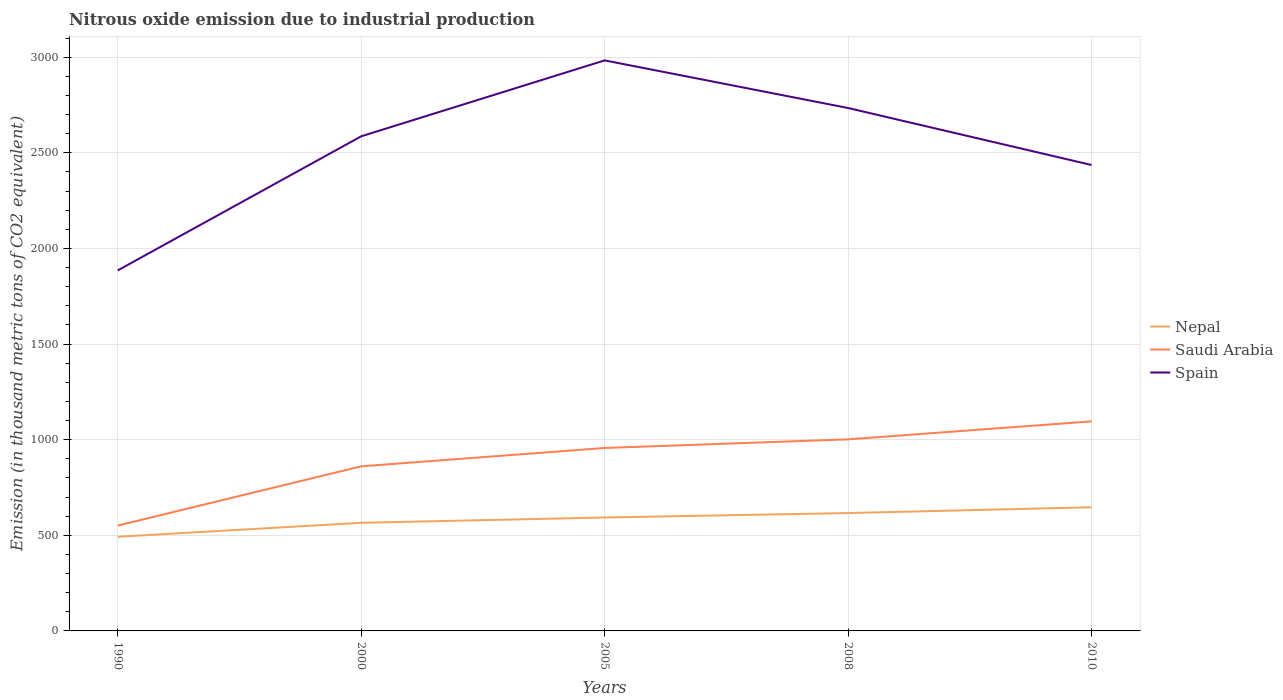Across all years, what is the maximum amount of nitrous oxide emitted in Spain?
Keep it short and to the point. 1885.3. What is the total amount of nitrous oxide emitted in Nepal in the graph?
Make the answer very short. -30.4. What is the difference between the highest and the second highest amount of nitrous oxide emitted in Nepal?
Keep it short and to the point. 154.3. What is the difference between the highest and the lowest amount of nitrous oxide emitted in Nepal?
Your answer should be very brief. 3. Is the amount of nitrous oxide emitted in Spain strictly greater than the amount of nitrous oxide emitted in Nepal over the years?
Your response must be concise. No. How many years are there in the graph?
Your answer should be very brief. 5. What is the difference between two consecutive major ticks on the Y-axis?
Keep it short and to the point. 500. Are the values on the major ticks of Y-axis written in scientific E-notation?
Offer a terse response. No. Does the graph contain any zero values?
Provide a succinct answer. No. Does the graph contain grids?
Provide a succinct answer. Yes. What is the title of the graph?
Ensure brevity in your answer.  Nitrous oxide emission due to industrial production. What is the label or title of the Y-axis?
Give a very brief answer. Emission (in thousand metric tons of CO2 equivalent). What is the Emission (in thousand metric tons of CO2 equivalent) of Nepal in 1990?
Provide a succinct answer. 492.4. What is the Emission (in thousand metric tons of CO2 equivalent) of Saudi Arabia in 1990?
Provide a succinct answer. 550.9. What is the Emission (in thousand metric tons of CO2 equivalent) of Spain in 1990?
Keep it short and to the point. 1885.3. What is the Emission (in thousand metric tons of CO2 equivalent) of Nepal in 2000?
Make the answer very short. 565.3. What is the Emission (in thousand metric tons of CO2 equivalent) of Saudi Arabia in 2000?
Make the answer very short. 860.7. What is the Emission (in thousand metric tons of CO2 equivalent) of Spain in 2000?
Your answer should be very brief. 2586.5. What is the Emission (in thousand metric tons of CO2 equivalent) of Nepal in 2005?
Give a very brief answer. 593.1. What is the Emission (in thousand metric tons of CO2 equivalent) in Saudi Arabia in 2005?
Your answer should be very brief. 956.7. What is the Emission (in thousand metric tons of CO2 equivalent) of Spain in 2005?
Your answer should be compact. 2983.4. What is the Emission (in thousand metric tons of CO2 equivalent) of Nepal in 2008?
Offer a very short reply. 616.3. What is the Emission (in thousand metric tons of CO2 equivalent) in Saudi Arabia in 2008?
Ensure brevity in your answer.  1001.7. What is the Emission (in thousand metric tons of CO2 equivalent) in Spain in 2008?
Your response must be concise. 2734.4. What is the Emission (in thousand metric tons of CO2 equivalent) of Nepal in 2010?
Your answer should be very brief. 646.7. What is the Emission (in thousand metric tons of CO2 equivalent) in Saudi Arabia in 2010?
Offer a terse response. 1095.8. What is the Emission (in thousand metric tons of CO2 equivalent) in Spain in 2010?
Keep it short and to the point. 2436.4. Across all years, what is the maximum Emission (in thousand metric tons of CO2 equivalent) in Nepal?
Provide a succinct answer. 646.7. Across all years, what is the maximum Emission (in thousand metric tons of CO2 equivalent) of Saudi Arabia?
Give a very brief answer. 1095.8. Across all years, what is the maximum Emission (in thousand metric tons of CO2 equivalent) in Spain?
Your answer should be very brief. 2983.4. Across all years, what is the minimum Emission (in thousand metric tons of CO2 equivalent) in Nepal?
Provide a short and direct response. 492.4. Across all years, what is the minimum Emission (in thousand metric tons of CO2 equivalent) in Saudi Arabia?
Your answer should be compact. 550.9. Across all years, what is the minimum Emission (in thousand metric tons of CO2 equivalent) of Spain?
Ensure brevity in your answer.  1885.3. What is the total Emission (in thousand metric tons of CO2 equivalent) of Nepal in the graph?
Offer a terse response. 2913.8. What is the total Emission (in thousand metric tons of CO2 equivalent) of Saudi Arabia in the graph?
Ensure brevity in your answer.  4465.8. What is the total Emission (in thousand metric tons of CO2 equivalent) of Spain in the graph?
Your answer should be compact. 1.26e+04. What is the difference between the Emission (in thousand metric tons of CO2 equivalent) of Nepal in 1990 and that in 2000?
Provide a short and direct response. -72.9. What is the difference between the Emission (in thousand metric tons of CO2 equivalent) in Saudi Arabia in 1990 and that in 2000?
Your answer should be very brief. -309.8. What is the difference between the Emission (in thousand metric tons of CO2 equivalent) of Spain in 1990 and that in 2000?
Keep it short and to the point. -701.2. What is the difference between the Emission (in thousand metric tons of CO2 equivalent) in Nepal in 1990 and that in 2005?
Give a very brief answer. -100.7. What is the difference between the Emission (in thousand metric tons of CO2 equivalent) of Saudi Arabia in 1990 and that in 2005?
Provide a short and direct response. -405.8. What is the difference between the Emission (in thousand metric tons of CO2 equivalent) of Spain in 1990 and that in 2005?
Keep it short and to the point. -1098.1. What is the difference between the Emission (in thousand metric tons of CO2 equivalent) in Nepal in 1990 and that in 2008?
Offer a very short reply. -123.9. What is the difference between the Emission (in thousand metric tons of CO2 equivalent) of Saudi Arabia in 1990 and that in 2008?
Provide a succinct answer. -450.8. What is the difference between the Emission (in thousand metric tons of CO2 equivalent) of Spain in 1990 and that in 2008?
Your answer should be very brief. -849.1. What is the difference between the Emission (in thousand metric tons of CO2 equivalent) in Nepal in 1990 and that in 2010?
Your answer should be very brief. -154.3. What is the difference between the Emission (in thousand metric tons of CO2 equivalent) of Saudi Arabia in 1990 and that in 2010?
Offer a very short reply. -544.9. What is the difference between the Emission (in thousand metric tons of CO2 equivalent) in Spain in 1990 and that in 2010?
Your answer should be very brief. -551.1. What is the difference between the Emission (in thousand metric tons of CO2 equivalent) of Nepal in 2000 and that in 2005?
Offer a terse response. -27.8. What is the difference between the Emission (in thousand metric tons of CO2 equivalent) in Saudi Arabia in 2000 and that in 2005?
Provide a succinct answer. -96. What is the difference between the Emission (in thousand metric tons of CO2 equivalent) of Spain in 2000 and that in 2005?
Ensure brevity in your answer.  -396.9. What is the difference between the Emission (in thousand metric tons of CO2 equivalent) in Nepal in 2000 and that in 2008?
Keep it short and to the point. -51. What is the difference between the Emission (in thousand metric tons of CO2 equivalent) in Saudi Arabia in 2000 and that in 2008?
Provide a succinct answer. -141. What is the difference between the Emission (in thousand metric tons of CO2 equivalent) in Spain in 2000 and that in 2008?
Provide a succinct answer. -147.9. What is the difference between the Emission (in thousand metric tons of CO2 equivalent) in Nepal in 2000 and that in 2010?
Your answer should be compact. -81.4. What is the difference between the Emission (in thousand metric tons of CO2 equivalent) in Saudi Arabia in 2000 and that in 2010?
Ensure brevity in your answer.  -235.1. What is the difference between the Emission (in thousand metric tons of CO2 equivalent) of Spain in 2000 and that in 2010?
Keep it short and to the point. 150.1. What is the difference between the Emission (in thousand metric tons of CO2 equivalent) of Nepal in 2005 and that in 2008?
Keep it short and to the point. -23.2. What is the difference between the Emission (in thousand metric tons of CO2 equivalent) in Saudi Arabia in 2005 and that in 2008?
Provide a short and direct response. -45. What is the difference between the Emission (in thousand metric tons of CO2 equivalent) in Spain in 2005 and that in 2008?
Offer a terse response. 249. What is the difference between the Emission (in thousand metric tons of CO2 equivalent) in Nepal in 2005 and that in 2010?
Offer a very short reply. -53.6. What is the difference between the Emission (in thousand metric tons of CO2 equivalent) of Saudi Arabia in 2005 and that in 2010?
Offer a very short reply. -139.1. What is the difference between the Emission (in thousand metric tons of CO2 equivalent) of Spain in 2005 and that in 2010?
Offer a very short reply. 547. What is the difference between the Emission (in thousand metric tons of CO2 equivalent) of Nepal in 2008 and that in 2010?
Your answer should be very brief. -30.4. What is the difference between the Emission (in thousand metric tons of CO2 equivalent) in Saudi Arabia in 2008 and that in 2010?
Keep it short and to the point. -94.1. What is the difference between the Emission (in thousand metric tons of CO2 equivalent) in Spain in 2008 and that in 2010?
Offer a terse response. 298. What is the difference between the Emission (in thousand metric tons of CO2 equivalent) in Nepal in 1990 and the Emission (in thousand metric tons of CO2 equivalent) in Saudi Arabia in 2000?
Make the answer very short. -368.3. What is the difference between the Emission (in thousand metric tons of CO2 equivalent) in Nepal in 1990 and the Emission (in thousand metric tons of CO2 equivalent) in Spain in 2000?
Give a very brief answer. -2094.1. What is the difference between the Emission (in thousand metric tons of CO2 equivalent) in Saudi Arabia in 1990 and the Emission (in thousand metric tons of CO2 equivalent) in Spain in 2000?
Your answer should be very brief. -2035.6. What is the difference between the Emission (in thousand metric tons of CO2 equivalent) in Nepal in 1990 and the Emission (in thousand metric tons of CO2 equivalent) in Saudi Arabia in 2005?
Give a very brief answer. -464.3. What is the difference between the Emission (in thousand metric tons of CO2 equivalent) of Nepal in 1990 and the Emission (in thousand metric tons of CO2 equivalent) of Spain in 2005?
Provide a short and direct response. -2491. What is the difference between the Emission (in thousand metric tons of CO2 equivalent) in Saudi Arabia in 1990 and the Emission (in thousand metric tons of CO2 equivalent) in Spain in 2005?
Keep it short and to the point. -2432.5. What is the difference between the Emission (in thousand metric tons of CO2 equivalent) in Nepal in 1990 and the Emission (in thousand metric tons of CO2 equivalent) in Saudi Arabia in 2008?
Keep it short and to the point. -509.3. What is the difference between the Emission (in thousand metric tons of CO2 equivalent) of Nepal in 1990 and the Emission (in thousand metric tons of CO2 equivalent) of Spain in 2008?
Keep it short and to the point. -2242. What is the difference between the Emission (in thousand metric tons of CO2 equivalent) in Saudi Arabia in 1990 and the Emission (in thousand metric tons of CO2 equivalent) in Spain in 2008?
Keep it short and to the point. -2183.5. What is the difference between the Emission (in thousand metric tons of CO2 equivalent) in Nepal in 1990 and the Emission (in thousand metric tons of CO2 equivalent) in Saudi Arabia in 2010?
Keep it short and to the point. -603.4. What is the difference between the Emission (in thousand metric tons of CO2 equivalent) in Nepal in 1990 and the Emission (in thousand metric tons of CO2 equivalent) in Spain in 2010?
Your answer should be compact. -1944. What is the difference between the Emission (in thousand metric tons of CO2 equivalent) of Saudi Arabia in 1990 and the Emission (in thousand metric tons of CO2 equivalent) of Spain in 2010?
Your response must be concise. -1885.5. What is the difference between the Emission (in thousand metric tons of CO2 equivalent) of Nepal in 2000 and the Emission (in thousand metric tons of CO2 equivalent) of Saudi Arabia in 2005?
Offer a terse response. -391.4. What is the difference between the Emission (in thousand metric tons of CO2 equivalent) in Nepal in 2000 and the Emission (in thousand metric tons of CO2 equivalent) in Spain in 2005?
Offer a very short reply. -2418.1. What is the difference between the Emission (in thousand metric tons of CO2 equivalent) in Saudi Arabia in 2000 and the Emission (in thousand metric tons of CO2 equivalent) in Spain in 2005?
Provide a succinct answer. -2122.7. What is the difference between the Emission (in thousand metric tons of CO2 equivalent) in Nepal in 2000 and the Emission (in thousand metric tons of CO2 equivalent) in Saudi Arabia in 2008?
Ensure brevity in your answer.  -436.4. What is the difference between the Emission (in thousand metric tons of CO2 equivalent) of Nepal in 2000 and the Emission (in thousand metric tons of CO2 equivalent) of Spain in 2008?
Your answer should be compact. -2169.1. What is the difference between the Emission (in thousand metric tons of CO2 equivalent) in Saudi Arabia in 2000 and the Emission (in thousand metric tons of CO2 equivalent) in Spain in 2008?
Your answer should be very brief. -1873.7. What is the difference between the Emission (in thousand metric tons of CO2 equivalent) in Nepal in 2000 and the Emission (in thousand metric tons of CO2 equivalent) in Saudi Arabia in 2010?
Your answer should be very brief. -530.5. What is the difference between the Emission (in thousand metric tons of CO2 equivalent) in Nepal in 2000 and the Emission (in thousand metric tons of CO2 equivalent) in Spain in 2010?
Make the answer very short. -1871.1. What is the difference between the Emission (in thousand metric tons of CO2 equivalent) in Saudi Arabia in 2000 and the Emission (in thousand metric tons of CO2 equivalent) in Spain in 2010?
Your response must be concise. -1575.7. What is the difference between the Emission (in thousand metric tons of CO2 equivalent) of Nepal in 2005 and the Emission (in thousand metric tons of CO2 equivalent) of Saudi Arabia in 2008?
Offer a very short reply. -408.6. What is the difference between the Emission (in thousand metric tons of CO2 equivalent) of Nepal in 2005 and the Emission (in thousand metric tons of CO2 equivalent) of Spain in 2008?
Give a very brief answer. -2141.3. What is the difference between the Emission (in thousand metric tons of CO2 equivalent) of Saudi Arabia in 2005 and the Emission (in thousand metric tons of CO2 equivalent) of Spain in 2008?
Provide a short and direct response. -1777.7. What is the difference between the Emission (in thousand metric tons of CO2 equivalent) in Nepal in 2005 and the Emission (in thousand metric tons of CO2 equivalent) in Saudi Arabia in 2010?
Provide a succinct answer. -502.7. What is the difference between the Emission (in thousand metric tons of CO2 equivalent) of Nepal in 2005 and the Emission (in thousand metric tons of CO2 equivalent) of Spain in 2010?
Provide a short and direct response. -1843.3. What is the difference between the Emission (in thousand metric tons of CO2 equivalent) of Saudi Arabia in 2005 and the Emission (in thousand metric tons of CO2 equivalent) of Spain in 2010?
Make the answer very short. -1479.7. What is the difference between the Emission (in thousand metric tons of CO2 equivalent) of Nepal in 2008 and the Emission (in thousand metric tons of CO2 equivalent) of Saudi Arabia in 2010?
Give a very brief answer. -479.5. What is the difference between the Emission (in thousand metric tons of CO2 equivalent) in Nepal in 2008 and the Emission (in thousand metric tons of CO2 equivalent) in Spain in 2010?
Give a very brief answer. -1820.1. What is the difference between the Emission (in thousand metric tons of CO2 equivalent) in Saudi Arabia in 2008 and the Emission (in thousand metric tons of CO2 equivalent) in Spain in 2010?
Your answer should be compact. -1434.7. What is the average Emission (in thousand metric tons of CO2 equivalent) in Nepal per year?
Offer a very short reply. 582.76. What is the average Emission (in thousand metric tons of CO2 equivalent) of Saudi Arabia per year?
Keep it short and to the point. 893.16. What is the average Emission (in thousand metric tons of CO2 equivalent) in Spain per year?
Your answer should be very brief. 2525.2. In the year 1990, what is the difference between the Emission (in thousand metric tons of CO2 equivalent) of Nepal and Emission (in thousand metric tons of CO2 equivalent) of Saudi Arabia?
Ensure brevity in your answer.  -58.5. In the year 1990, what is the difference between the Emission (in thousand metric tons of CO2 equivalent) of Nepal and Emission (in thousand metric tons of CO2 equivalent) of Spain?
Ensure brevity in your answer.  -1392.9. In the year 1990, what is the difference between the Emission (in thousand metric tons of CO2 equivalent) of Saudi Arabia and Emission (in thousand metric tons of CO2 equivalent) of Spain?
Keep it short and to the point. -1334.4. In the year 2000, what is the difference between the Emission (in thousand metric tons of CO2 equivalent) of Nepal and Emission (in thousand metric tons of CO2 equivalent) of Saudi Arabia?
Provide a short and direct response. -295.4. In the year 2000, what is the difference between the Emission (in thousand metric tons of CO2 equivalent) in Nepal and Emission (in thousand metric tons of CO2 equivalent) in Spain?
Offer a terse response. -2021.2. In the year 2000, what is the difference between the Emission (in thousand metric tons of CO2 equivalent) in Saudi Arabia and Emission (in thousand metric tons of CO2 equivalent) in Spain?
Provide a succinct answer. -1725.8. In the year 2005, what is the difference between the Emission (in thousand metric tons of CO2 equivalent) of Nepal and Emission (in thousand metric tons of CO2 equivalent) of Saudi Arabia?
Keep it short and to the point. -363.6. In the year 2005, what is the difference between the Emission (in thousand metric tons of CO2 equivalent) of Nepal and Emission (in thousand metric tons of CO2 equivalent) of Spain?
Your answer should be compact. -2390.3. In the year 2005, what is the difference between the Emission (in thousand metric tons of CO2 equivalent) in Saudi Arabia and Emission (in thousand metric tons of CO2 equivalent) in Spain?
Provide a succinct answer. -2026.7. In the year 2008, what is the difference between the Emission (in thousand metric tons of CO2 equivalent) in Nepal and Emission (in thousand metric tons of CO2 equivalent) in Saudi Arabia?
Your answer should be compact. -385.4. In the year 2008, what is the difference between the Emission (in thousand metric tons of CO2 equivalent) in Nepal and Emission (in thousand metric tons of CO2 equivalent) in Spain?
Provide a succinct answer. -2118.1. In the year 2008, what is the difference between the Emission (in thousand metric tons of CO2 equivalent) of Saudi Arabia and Emission (in thousand metric tons of CO2 equivalent) of Spain?
Offer a very short reply. -1732.7. In the year 2010, what is the difference between the Emission (in thousand metric tons of CO2 equivalent) of Nepal and Emission (in thousand metric tons of CO2 equivalent) of Saudi Arabia?
Give a very brief answer. -449.1. In the year 2010, what is the difference between the Emission (in thousand metric tons of CO2 equivalent) of Nepal and Emission (in thousand metric tons of CO2 equivalent) of Spain?
Keep it short and to the point. -1789.7. In the year 2010, what is the difference between the Emission (in thousand metric tons of CO2 equivalent) of Saudi Arabia and Emission (in thousand metric tons of CO2 equivalent) of Spain?
Provide a succinct answer. -1340.6. What is the ratio of the Emission (in thousand metric tons of CO2 equivalent) of Nepal in 1990 to that in 2000?
Your response must be concise. 0.87. What is the ratio of the Emission (in thousand metric tons of CO2 equivalent) in Saudi Arabia in 1990 to that in 2000?
Offer a terse response. 0.64. What is the ratio of the Emission (in thousand metric tons of CO2 equivalent) in Spain in 1990 to that in 2000?
Keep it short and to the point. 0.73. What is the ratio of the Emission (in thousand metric tons of CO2 equivalent) in Nepal in 1990 to that in 2005?
Your answer should be compact. 0.83. What is the ratio of the Emission (in thousand metric tons of CO2 equivalent) of Saudi Arabia in 1990 to that in 2005?
Offer a terse response. 0.58. What is the ratio of the Emission (in thousand metric tons of CO2 equivalent) in Spain in 1990 to that in 2005?
Ensure brevity in your answer.  0.63. What is the ratio of the Emission (in thousand metric tons of CO2 equivalent) in Nepal in 1990 to that in 2008?
Give a very brief answer. 0.8. What is the ratio of the Emission (in thousand metric tons of CO2 equivalent) of Saudi Arabia in 1990 to that in 2008?
Give a very brief answer. 0.55. What is the ratio of the Emission (in thousand metric tons of CO2 equivalent) of Spain in 1990 to that in 2008?
Your answer should be very brief. 0.69. What is the ratio of the Emission (in thousand metric tons of CO2 equivalent) of Nepal in 1990 to that in 2010?
Ensure brevity in your answer.  0.76. What is the ratio of the Emission (in thousand metric tons of CO2 equivalent) in Saudi Arabia in 1990 to that in 2010?
Your answer should be compact. 0.5. What is the ratio of the Emission (in thousand metric tons of CO2 equivalent) in Spain in 1990 to that in 2010?
Make the answer very short. 0.77. What is the ratio of the Emission (in thousand metric tons of CO2 equivalent) in Nepal in 2000 to that in 2005?
Give a very brief answer. 0.95. What is the ratio of the Emission (in thousand metric tons of CO2 equivalent) of Saudi Arabia in 2000 to that in 2005?
Your answer should be very brief. 0.9. What is the ratio of the Emission (in thousand metric tons of CO2 equivalent) in Spain in 2000 to that in 2005?
Offer a very short reply. 0.87. What is the ratio of the Emission (in thousand metric tons of CO2 equivalent) of Nepal in 2000 to that in 2008?
Provide a short and direct response. 0.92. What is the ratio of the Emission (in thousand metric tons of CO2 equivalent) of Saudi Arabia in 2000 to that in 2008?
Offer a terse response. 0.86. What is the ratio of the Emission (in thousand metric tons of CO2 equivalent) of Spain in 2000 to that in 2008?
Provide a short and direct response. 0.95. What is the ratio of the Emission (in thousand metric tons of CO2 equivalent) in Nepal in 2000 to that in 2010?
Offer a terse response. 0.87. What is the ratio of the Emission (in thousand metric tons of CO2 equivalent) in Saudi Arabia in 2000 to that in 2010?
Provide a succinct answer. 0.79. What is the ratio of the Emission (in thousand metric tons of CO2 equivalent) of Spain in 2000 to that in 2010?
Ensure brevity in your answer.  1.06. What is the ratio of the Emission (in thousand metric tons of CO2 equivalent) in Nepal in 2005 to that in 2008?
Your response must be concise. 0.96. What is the ratio of the Emission (in thousand metric tons of CO2 equivalent) of Saudi Arabia in 2005 to that in 2008?
Offer a terse response. 0.96. What is the ratio of the Emission (in thousand metric tons of CO2 equivalent) of Spain in 2005 to that in 2008?
Provide a short and direct response. 1.09. What is the ratio of the Emission (in thousand metric tons of CO2 equivalent) of Nepal in 2005 to that in 2010?
Your response must be concise. 0.92. What is the ratio of the Emission (in thousand metric tons of CO2 equivalent) in Saudi Arabia in 2005 to that in 2010?
Ensure brevity in your answer.  0.87. What is the ratio of the Emission (in thousand metric tons of CO2 equivalent) of Spain in 2005 to that in 2010?
Your response must be concise. 1.22. What is the ratio of the Emission (in thousand metric tons of CO2 equivalent) of Nepal in 2008 to that in 2010?
Your answer should be compact. 0.95. What is the ratio of the Emission (in thousand metric tons of CO2 equivalent) in Saudi Arabia in 2008 to that in 2010?
Your answer should be very brief. 0.91. What is the ratio of the Emission (in thousand metric tons of CO2 equivalent) in Spain in 2008 to that in 2010?
Make the answer very short. 1.12. What is the difference between the highest and the second highest Emission (in thousand metric tons of CO2 equivalent) of Nepal?
Your answer should be compact. 30.4. What is the difference between the highest and the second highest Emission (in thousand metric tons of CO2 equivalent) in Saudi Arabia?
Your answer should be very brief. 94.1. What is the difference between the highest and the second highest Emission (in thousand metric tons of CO2 equivalent) of Spain?
Give a very brief answer. 249. What is the difference between the highest and the lowest Emission (in thousand metric tons of CO2 equivalent) of Nepal?
Your answer should be very brief. 154.3. What is the difference between the highest and the lowest Emission (in thousand metric tons of CO2 equivalent) in Saudi Arabia?
Your answer should be very brief. 544.9. What is the difference between the highest and the lowest Emission (in thousand metric tons of CO2 equivalent) of Spain?
Your answer should be compact. 1098.1. 